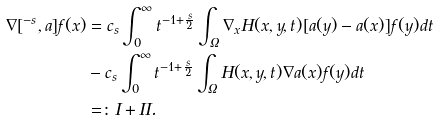<formula> <loc_0><loc_0><loc_500><loc_500>\nabla [ \L ^ { - s } , a ] f ( x ) & = c _ { s } \int _ { 0 } ^ { \infty } t ^ { - 1 + \frac { s } { 2 } } \int _ { \Omega } \nabla _ { x } H ( x , y , t ) [ a ( y ) - a ( x ) ] f ( y ) d t \\ & - c _ { s } \int _ { 0 } ^ { \infty } t ^ { - 1 + \frac { s } { 2 } } \int _ { \Omega } H ( x , y , t ) \nabla a ( x ) f ( y ) d t \\ & = \colon I + I I .</formula> 